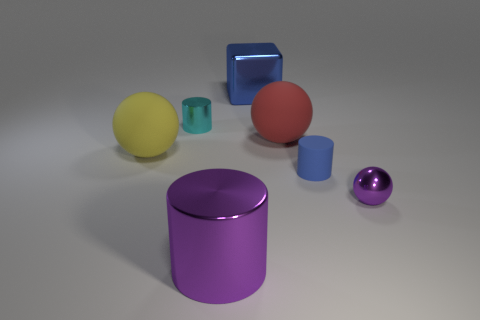What material do the objects seem to be made of? The objects in the image appear to be made of materials with a reflective quality, suggesting that they could be metals or plastics with a glossy finish. 